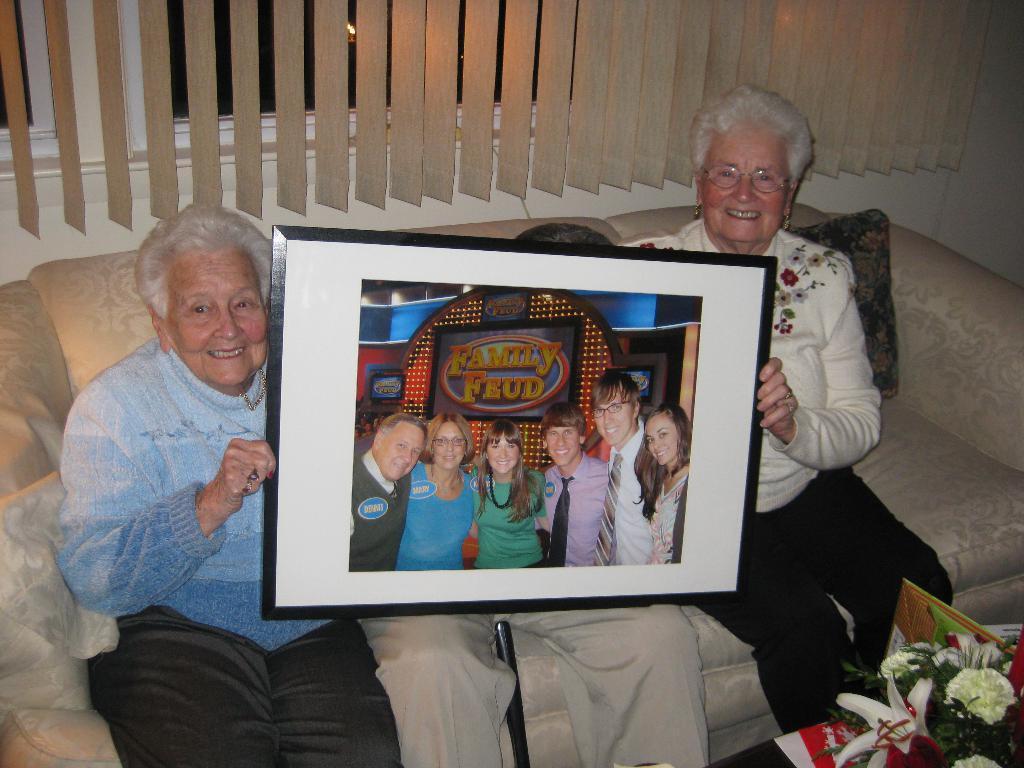How would you summarize this image in a sentence or two? In the center of the image we can see people sitting on the sofa and holding a photo frame in their hands, before them there is a bouquet. In the background there is a window and a curtain. 